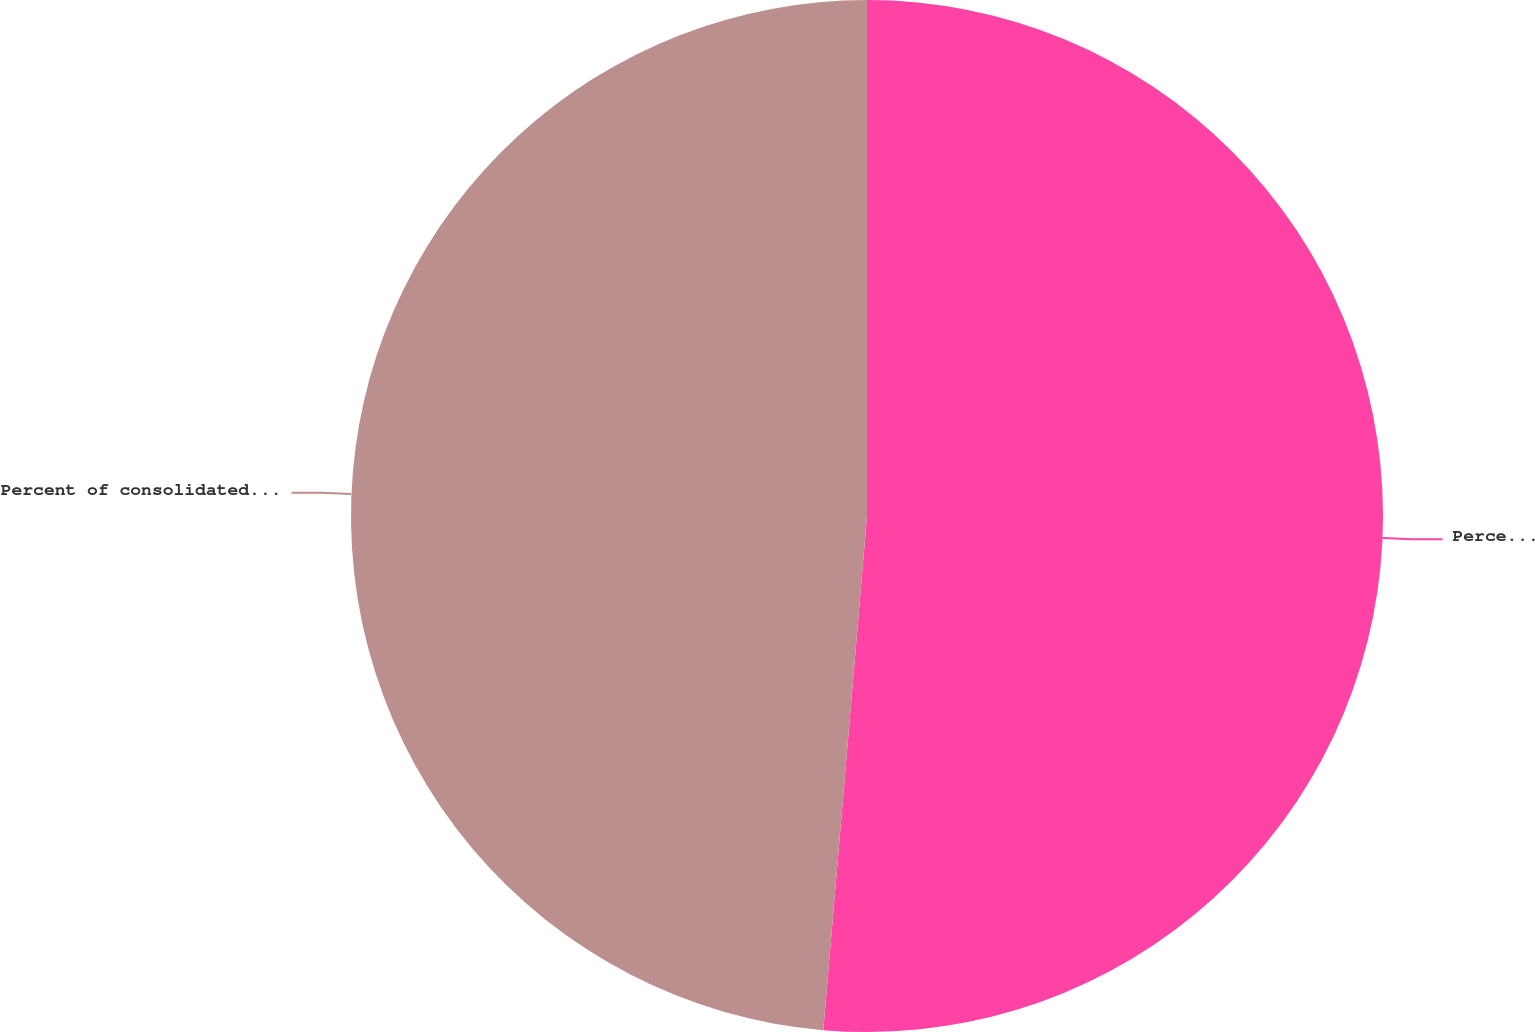Convert chart. <chart><loc_0><loc_0><loc_500><loc_500><pie_chart><fcel>Percent of consolidated net<fcel>Percent of consolidated EBIT<nl><fcel>51.35%<fcel>48.65%<nl></chart> 